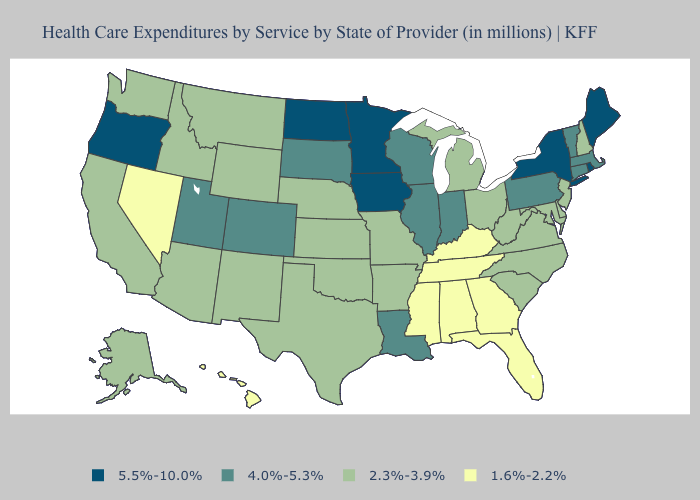Name the states that have a value in the range 4.0%-5.3%?
Answer briefly. Colorado, Connecticut, Illinois, Indiana, Louisiana, Massachusetts, Pennsylvania, South Dakota, Utah, Vermont, Wisconsin. Which states hav the highest value in the MidWest?
Give a very brief answer. Iowa, Minnesota, North Dakota. What is the highest value in the West ?
Be succinct. 5.5%-10.0%. Among the states that border Rhode Island , which have the highest value?
Write a very short answer. Connecticut, Massachusetts. Does Vermont have a lower value than New York?
Write a very short answer. Yes. Name the states that have a value in the range 1.6%-2.2%?
Give a very brief answer. Alabama, Florida, Georgia, Hawaii, Kentucky, Mississippi, Nevada, Tennessee. Which states have the lowest value in the USA?
Answer briefly. Alabama, Florida, Georgia, Hawaii, Kentucky, Mississippi, Nevada, Tennessee. Does Maine have the lowest value in the Northeast?
Write a very short answer. No. Name the states that have a value in the range 2.3%-3.9%?
Answer briefly. Alaska, Arizona, Arkansas, California, Delaware, Idaho, Kansas, Maryland, Michigan, Missouri, Montana, Nebraska, New Hampshire, New Jersey, New Mexico, North Carolina, Ohio, Oklahoma, South Carolina, Texas, Virginia, Washington, West Virginia, Wyoming. What is the value of Kansas?
Concise answer only. 2.3%-3.9%. Does Idaho have a higher value than Florida?
Answer briefly. Yes. What is the value of Connecticut?
Answer briefly. 4.0%-5.3%. Is the legend a continuous bar?
Answer briefly. No. How many symbols are there in the legend?
Be succinct. 4. What is the highest value in states that border West Virginia?
Keep it brief. 4.0%-5.3%. 